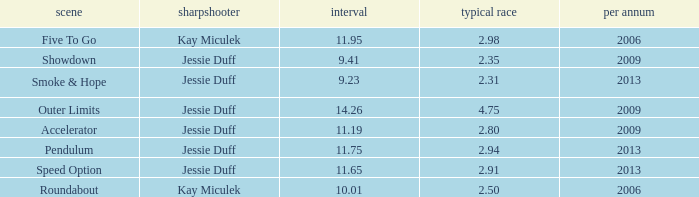Give me the full table as a dictionary. {'header': ['scene', 'sharpshooter', 'interval', 'typical race', 'per annum'], 'rows': [['Five To Go', 'Kay Miculek', '11.95', '2.98', '2006'], ['Showdown', 'Jessie Duff', '9.41', '2.35', '2009'], ['Smoke & Hope', 'Jessie Duff', '9.23', '2.31', '2013'], ['Outer Limits', 'Jessie Duff', '14.26', '4.75', '2009'], ['Accelerator', 'Jessie Duff', '11.19', '2.80', '2009'], ['Pendulum', 'Jessie Duff', '11.75', '2.94', '2013'], ['Speed Option', 'Jessie Duff', '11.65', '2.91', '2013'], ['Roundabout', 'Kay Miculek', '10.01', '2.50', '2006']]} What is the total amount of time for years prior to 2013 when speed option is the stage? None. 